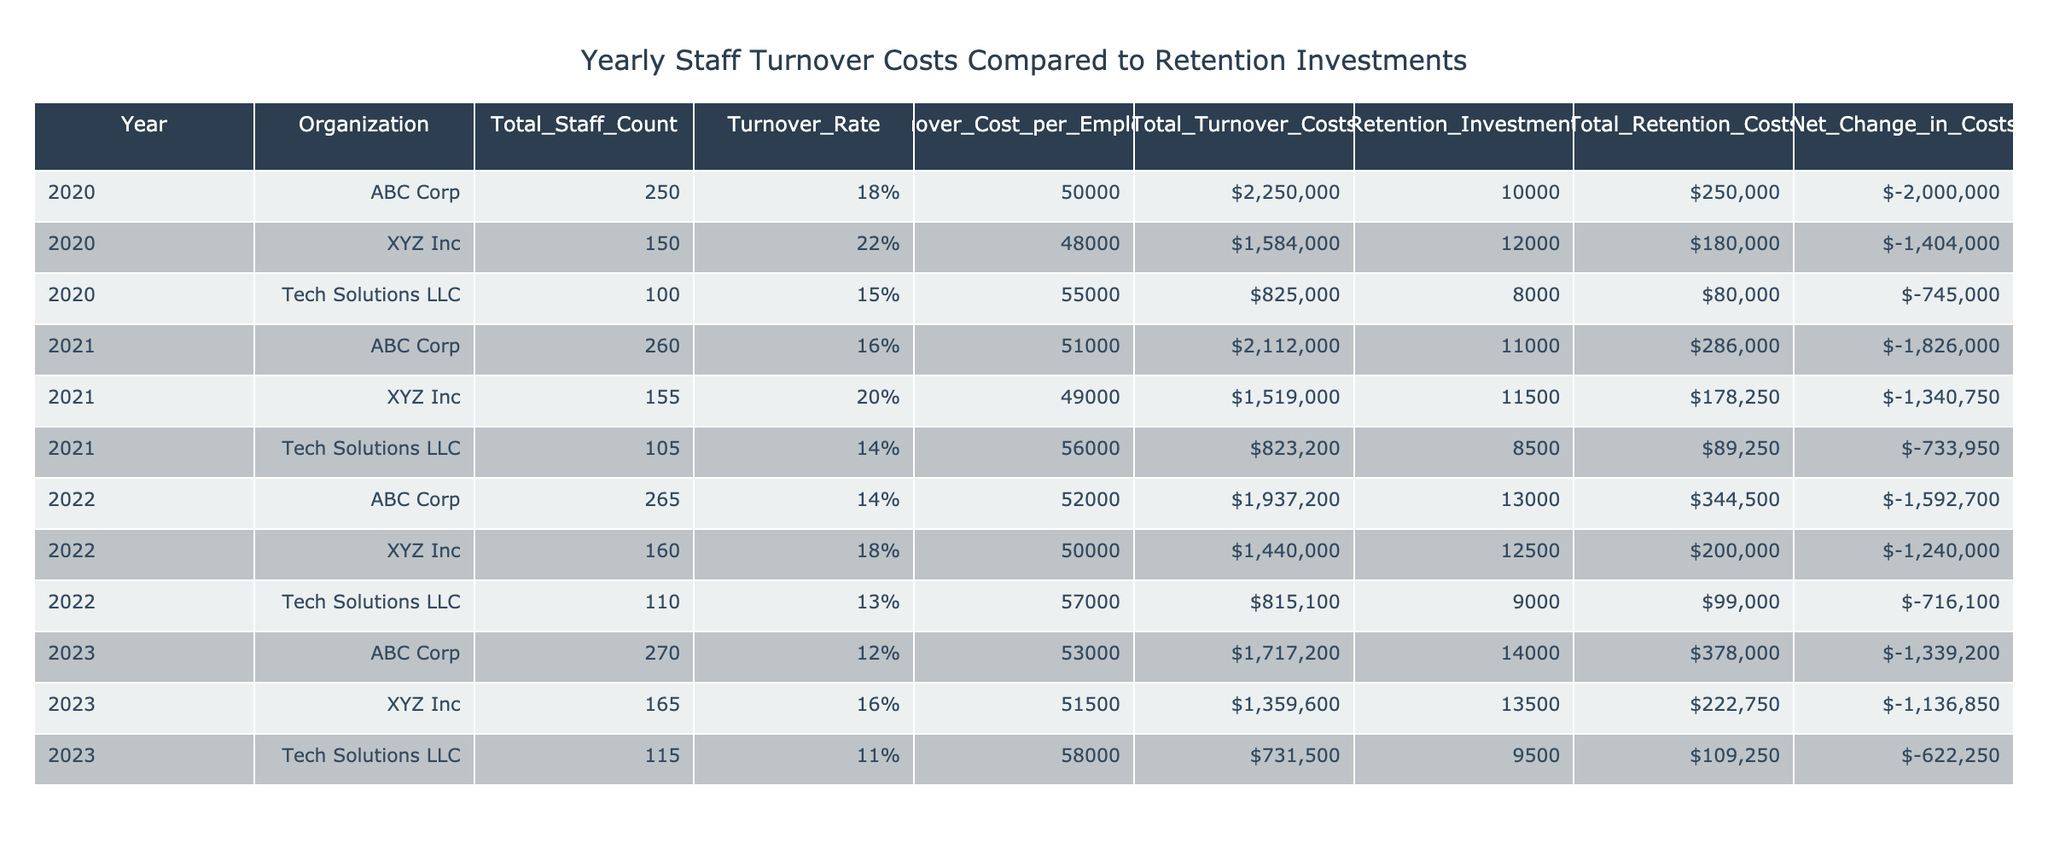What was the turnover rate for Tech Solutions LLC in 2023? In the row for Tech Solutions LLC for the year 2023, the turnover rate is listed as 0.11.
Answer: 0.11 What was the total retention costs for ABC Corp in 2022? Referring to the row for ABC Corp in 2022, the total retention costs are shown as $344,500.
Answer: $344,500 Which organization had the highest total turnover costs in 2021? In the year 2021, the total turnover costs for ABC Corp are $2,112,000, which is higher than both XYZ Inc and Tech Solutions LLC.
Answer: ABC Corp What is the net change in costs for XYZ Inc in 2023? Examining the row for XYZ Inc in 2023, the net change in costs is listed as -$1,136,850.
Answer: -$1,136,850 Did Tech Solutions LLC have a lower turnover rate in 2023 compared to 2022? In 2023, the turnover rate for Tech Solutions LLC is 0.11, while in 2022 it was 0.13. Since 0.11 is lower than 0.13, the answer is yes.
Answer: Yes What are the total turnover costs for all years combined for ABC Corp? Summing the total turnover costs of ABC Corp from 2020 to 2023: $2,250,000 (2020) + $2,112,000 (2021) + $1,937,200 (2022) + $1,717,200 (2023) = $7,016,400.
Answer: $7,016,400 Which year saw the lowest turnover rate for Tech Solutions LLC? Checking the turnover rates across the given years for Tech Solutions LLC: 0.15 in 2020, 0.14 in 2021, 0.13 in 2022, and 0.11 in 2023. 2023 shows the lowest rate.
Answer: 2023 What was the retention investment for XYZ Inc in 2021? The retention investment for XYZ Inc in 2021 is clearly shown as $11,500.
Answer: $11,500 What is the average total turnover costs for all years across all organizations? To find the average total turnover costs, first sum all the total turnover costs: $2,250,000 + $1,584,000 + $825,000 + $2,112,000 + $1,519,000 + $815,100 + $1,717,200 + $1,359,600 + $731,500 = $12,250,400. Then, divide by the number of years (9): $12,250,400 / 9 = $1,361,600.
Answer: $1,361,600 